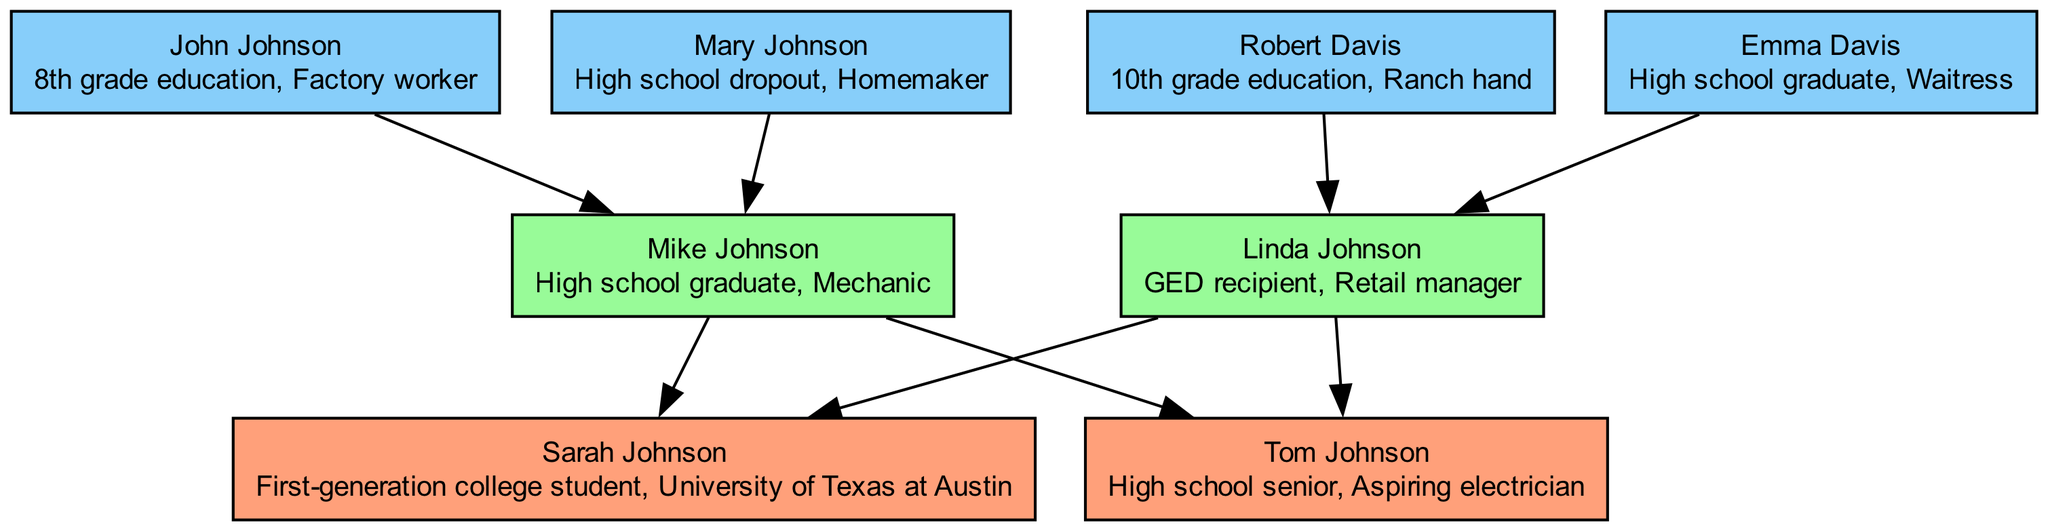What is Sarah Johnson's educational achievement? The diagram specifies that Sarah Johnson is a first-generation college student at the University of Texas at Austin, which directly answers the question regarding her educational achievement.
Answer: First-generation college student, University of Texas at Austin How many grandparents does Sarah Johnson have? By examining the diagram, it lists four grandparents: John Johnson, Mary Johnson, Robert Davis, and Emma Davis. Thus, the number of grandparents is four.
Answer: 4 What educational qualification does Linda Johnson have? The diagram indicates that Linda Johnson is a GED recipient, which refers to her educational qualification, as shown in her details within the diagram.
Answer: GED recipient Who is Sarah's sibling? The diagram indicates that Tom Johnson is listed as Sarah's sibling, making him her brother. This relationship is clearly stated in the sibling section of the diagram.
Answer: Tom Johnson What is Mike Johnson's occupation? According to the diagram, Mike Johnson is identified as a mechanic, which is explicitly mentioned in his details. This directly answers the question regarding his occupation.
Answer: Mechanic What is the highest level of education achieved by John Johnson? The diagram states that John Johnson has an 8th-grade education, representing the highest level of education he attained. This information can be found in the grandparents section of the diagram.
Answer: 8th grade education Which parent of Sarah Johnson holds a high school diploma? The diagram shows that Mike Johnson is a high school graduate, directly answering the question regarding which parent has completed high school.
Answer: Mike Johnson How is Emma Davis related to Sarah Johnson? The diagram illustrates that Emma Davis is Sarah's paternal grandmother, as she is the mother of Linda Johnson, Sarah's mother. This family line establishes the relationship clearly.
Answer: Grandmother What is Tom Johnson's current status in education? The diagram describes Tom Johnson as a high school senior, which indicates his current status in the educational system, revealing that he is still in school.
Answer: High school senior 